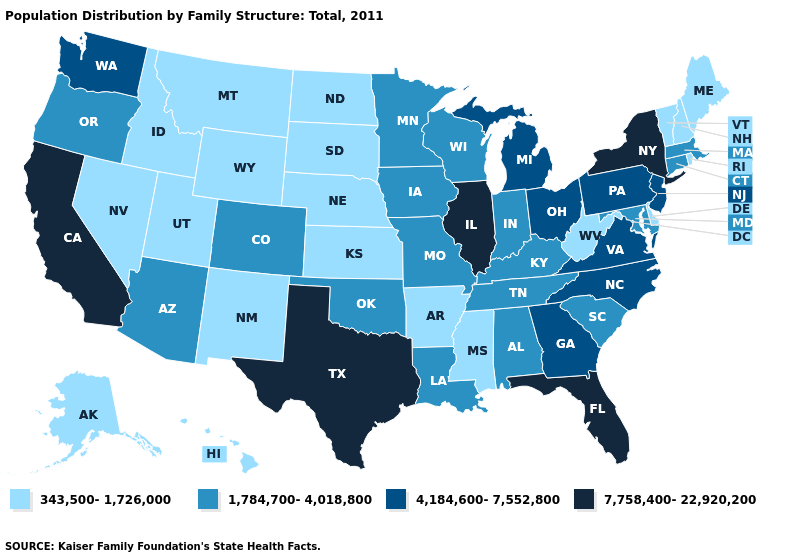What is the value of Nebraska?
Give a very brief answer. 343,500-1,726,000. What is the highest value in states that border Arizona?
Write a very short answer. 7,758,400-22,920,200. Among the states that border South Dakota , which have the highest value?
Answer briefly. Iowa, Minnesota. What is the value of Michigan?
Concise answer only. 4,184,600-7,552,800. Name the states that have a value in the range 4,184,600-7,552,800?
Quick response, please. Georgia, Michigan, New Jersey, North Carolina, Ohio, Pennsylvania, Virginia, Washington. What is the lowest value in the USA?
Write a very short answer. 343,500-1,726,000. Is the legend a continuous bar?
Write a very short answer. No. What is the value of Colorado?
Write a very short answer. 1,784,700-4,018,800. What is the lowest value in the West?
Short answer required. 343,500-1,726,000. Does New Hampshire have a lower value than Mississippi?
Short answer required. No. Name the states that have a value in the range 343,500-1,726,000?
Answer briefly. Alaska, Arkansas, Delaware, Hawaii, Idaho, Kansas, Maine, Mississippi, Montana, Nebraska, Nevada, New Hampshire, New Mexico, North Dakota, Rhode Island, South Dakota, Utah, Vermont, West Virginia, Wyoming. Does Wyoming have the lowest value in the USA?
Answer briefly. Yes. What is the lowest value in the USA?
Write a very short answer. 343,500-1,726,000. Among the states that border North Dakota , does Minnesota have the lowest value?
Write a very short answer. No. What is the highest value in the USA?
Short answer required. 7,758,400-22,920,200. 